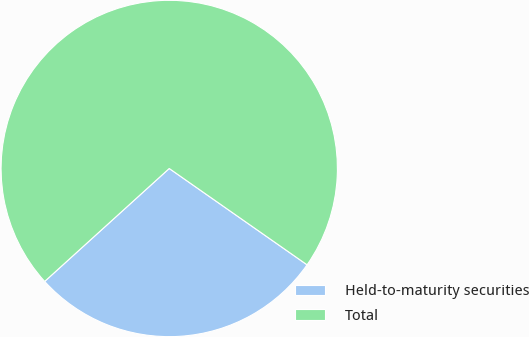Convert chart. <chart><loc_0><loc_0><loc_500><loc_500><pie_chart><fcel>Held-to-maturity securities<fcel>Total<nl><fcel>28.57%<fcel>71.43%<nl></chart> 